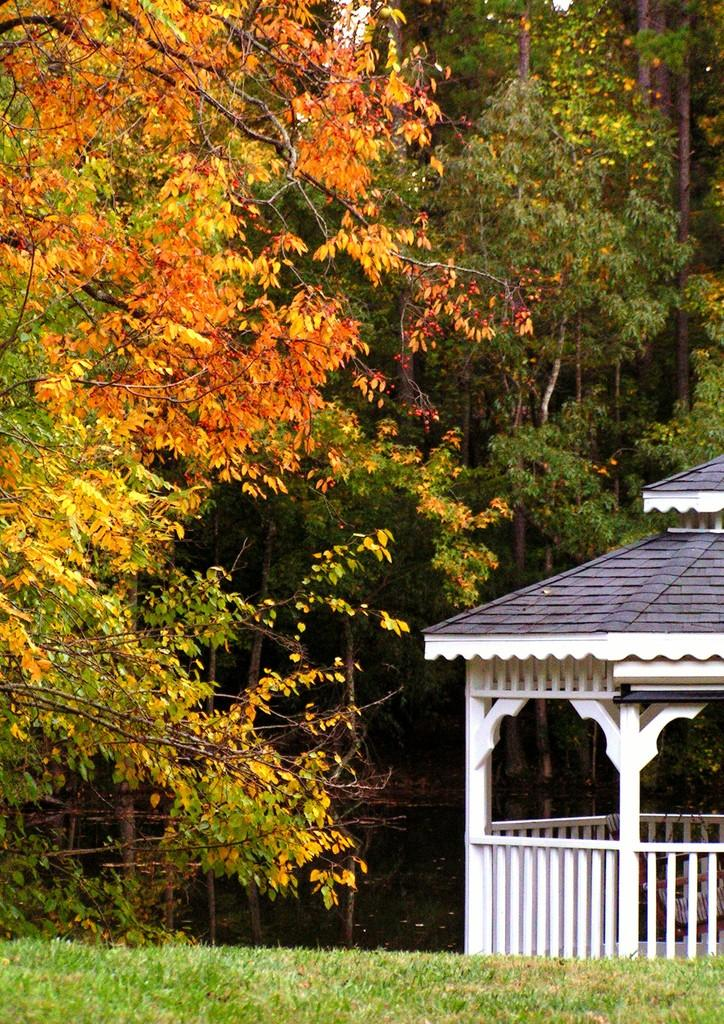What structure is located on the right side of the image? There is an open shed on the right side of the image. What type of furniture can be seen in the image? There is a chair in the image. What type of architectural feature is present in the image? There is railing in the image. What type of shelter is visible in the image? There is a roof in the image. What type of vegetation is present at the bottom of the image? Grass is present at the bottom of the image. What type of natural scenery can be seen in the background of the image? There are trees in the background of the image. Can you tell me where the father is sitting in the image? There is no father present in the image. What type of plantation can be seen in the background of the image? There is no plantation present in the image; only trees can be seen in the background. 